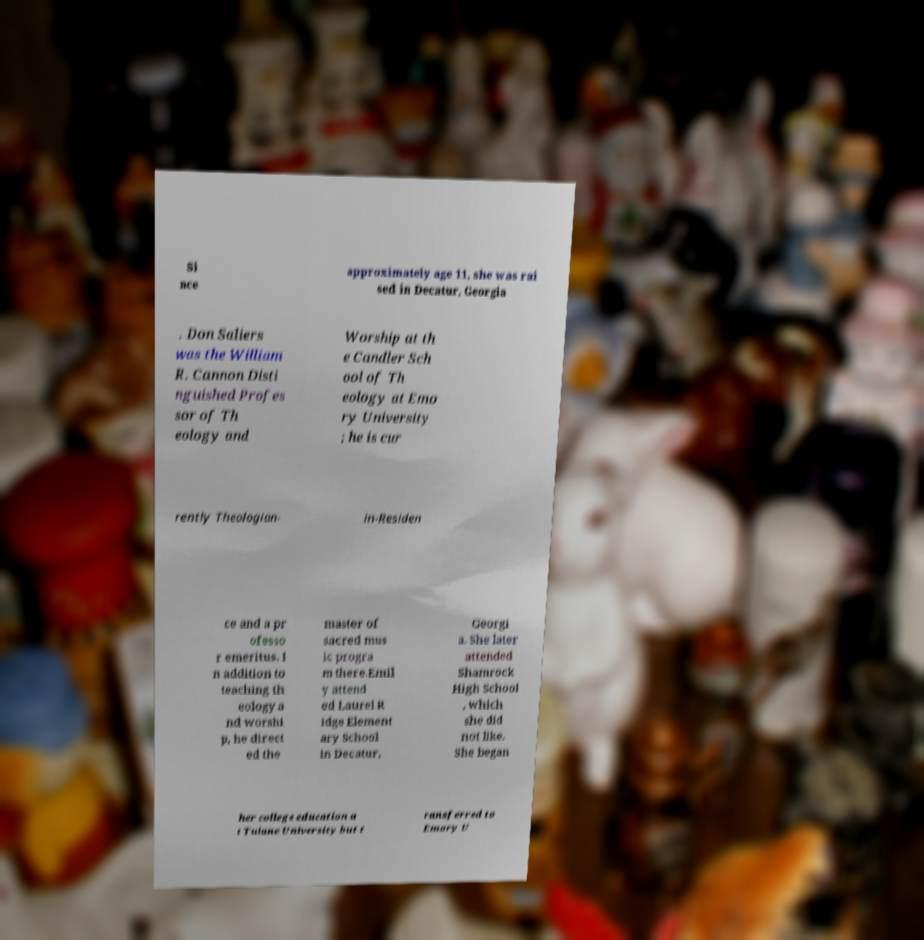There's text embedded in this image that I need extracted. Can you transcribe it verbatim? Si nce approximately age 11, she was rai sed in Decatur, Georgia . Don Saliers was the William R. Cannon Disti nguished Profes sor of Th eology and Worship at th e Candler Sch ool of Th eology at Emo ry University ; he is cur rently Theologian- in-Residen ce and a pr ofesso r emeritus. I n addition to teaching th eology a nd worshi p, he direct ed the master of sacred mus ic progra m there.Emil y attend ed Laurel R idge Element ary School in Decatur, Georgi a. She later attended Shamrock High School , which she did not like. She began her college education a t Tulane University but t ransferred to Emory U 